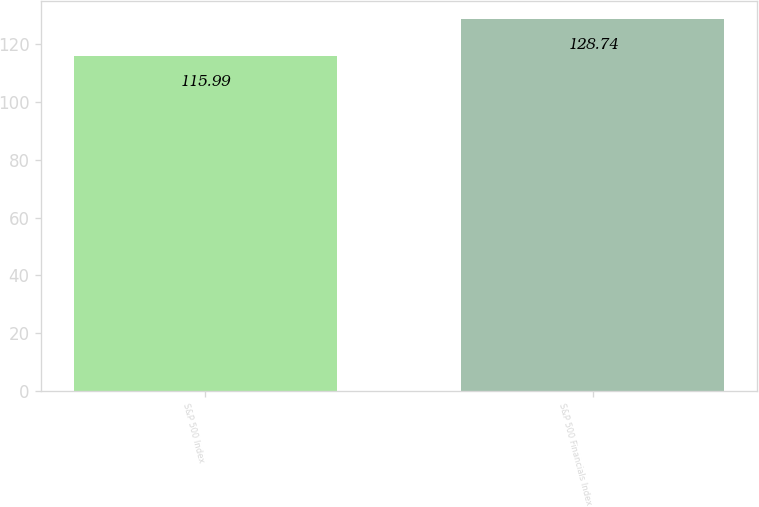<chart> <loc_0><loc_0><loc_500><loc_500><bar_chart><fcel>S&P 500 Index<fcel>S&P 500 Financials Index<nl><fcel>115.99<fcel>128.74<nl></chart> 